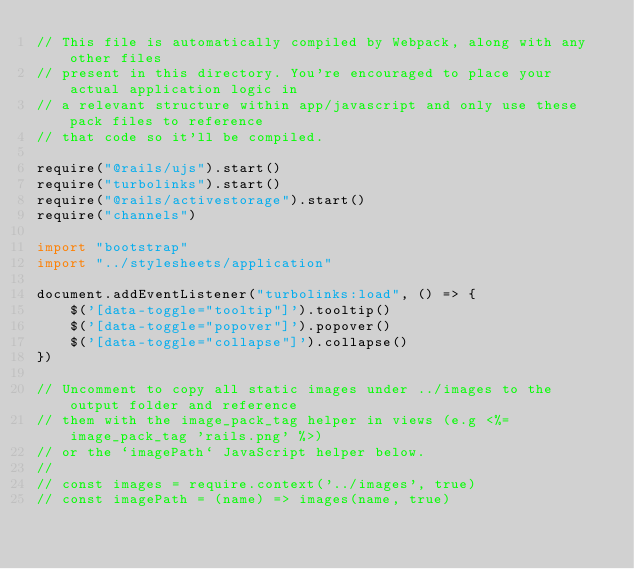<code> <loc_0><loc_0><loc_500><loc_500><_JavaScript_>// This file is automatically compiled by Webpack, along with any other files
// present in this directory. You're encouraged to place your actual application logic in
// a relevant structure within app/javascript and only use these pack files to reference
// that code so it'll be compiled.

require("@rails/ujs").start()
require("turbolinks").start()
require("@rails/activestorage").start()
require("channels")

import "bootstrap"
import "../stylesheets/application"

document.addEventListener("turbolinks:load", () => {
    $('[data-toggle="tooltip"]').tooltip()
    $('[data-toggle="popover"]').popover()
    $('[data-toggle="collapse"]').collapse()
})

// Uncomment to copy all static images under ../images to the output folder and reference
// them with the image_pack_tag helper in views (e.g <%= image_pack_tag 'rails.png' %>)
// or the `imagePath` JavaScript helper below.
//
// const images = require.context('../images', true)
// const imagePath = (name) => images(name, true)
</code> 